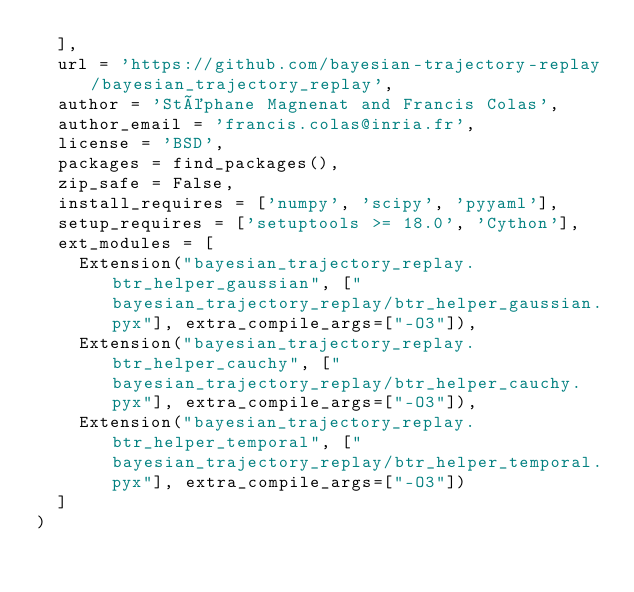Convert code to text. <code><loc_0><loc_0><loc_500><loc_500><_Python_>	],
	url = 'https://github.com/bayesian-trajectory-replay/bayesian_trajectory_replay',
	author = 'Stéphane Magnenat and Francis Colas',
	author_email = 'francis.colas@inria.fr',
	license = 'BSD',
	packages = find_packages(),
	zip_safe = False,
	install_requires = ['numpy', 'scipy', 'pyyaml'],
	setup_requires = ['setuptools >= 18.0', 'Cython'],
	ext_modules = [ 
		Extension("bayesian_trajectory_replay.btr_helper_gaussian", ["bayesian_trajectory_replay/btr_helper_gaussian.pyx"], extra_compile_args=["-O3"]),
		Extension("bayesian_trajectory_replay.btr_helper_cauchy", ["bayesian_trajectory_replay/btr_helper_cauchy.pyx"], extra_compile_args=["-O3"]),
		Extension("bayesian_trajectory_replay.btr_helper_temporal", ["bayesian_trajectory_replay/btr_helper_temporal.pyx"], extra_compile_args=["-O3"])
	]
)
</code> 